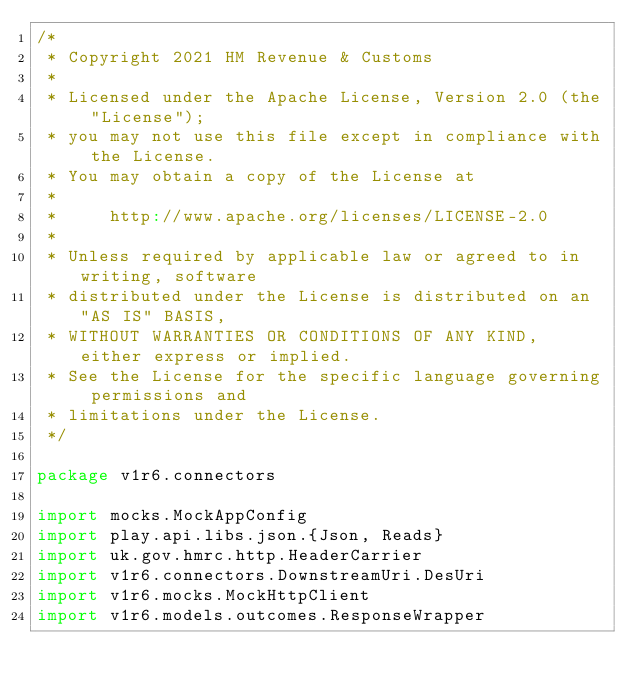<code> <loc_0><loc_0><loc_500><loc_500><_Scala_>/*
 * Copyright 2021 HM Revenue & Customs
 *
 * Licensed under the Apache License, Version 2.0 (the "License");
 * you may not use this file except in compliance with the License.
 * You may obtain a copy of the License at
 *
 *     http://www.apache.org/licenses/LICENSE-2.0
 *
 * Unless required by applicable law or agreed to in writing, software
 * distributed under the License is distributed on an "AS IS" BASIS,
 * WITHOUT WARRANTIES OR CONDITIONS OF ANY KIND, either express or implied.
 * See the License for the specific language governing permissions and
 * limitations under the License.
 */

package v1r6.connectors

import mocks.MockAppConfig
import play.api.libs.json.{Json, Reads}
import uk.gov.hmrc.http.HeaderCarrier
import v1r6.connectors.DownstreamUri.DesUri
import v1r6.mocks.MockHttpClient
import v1r6.models.outcomes.ResponseWrapper
</code> 